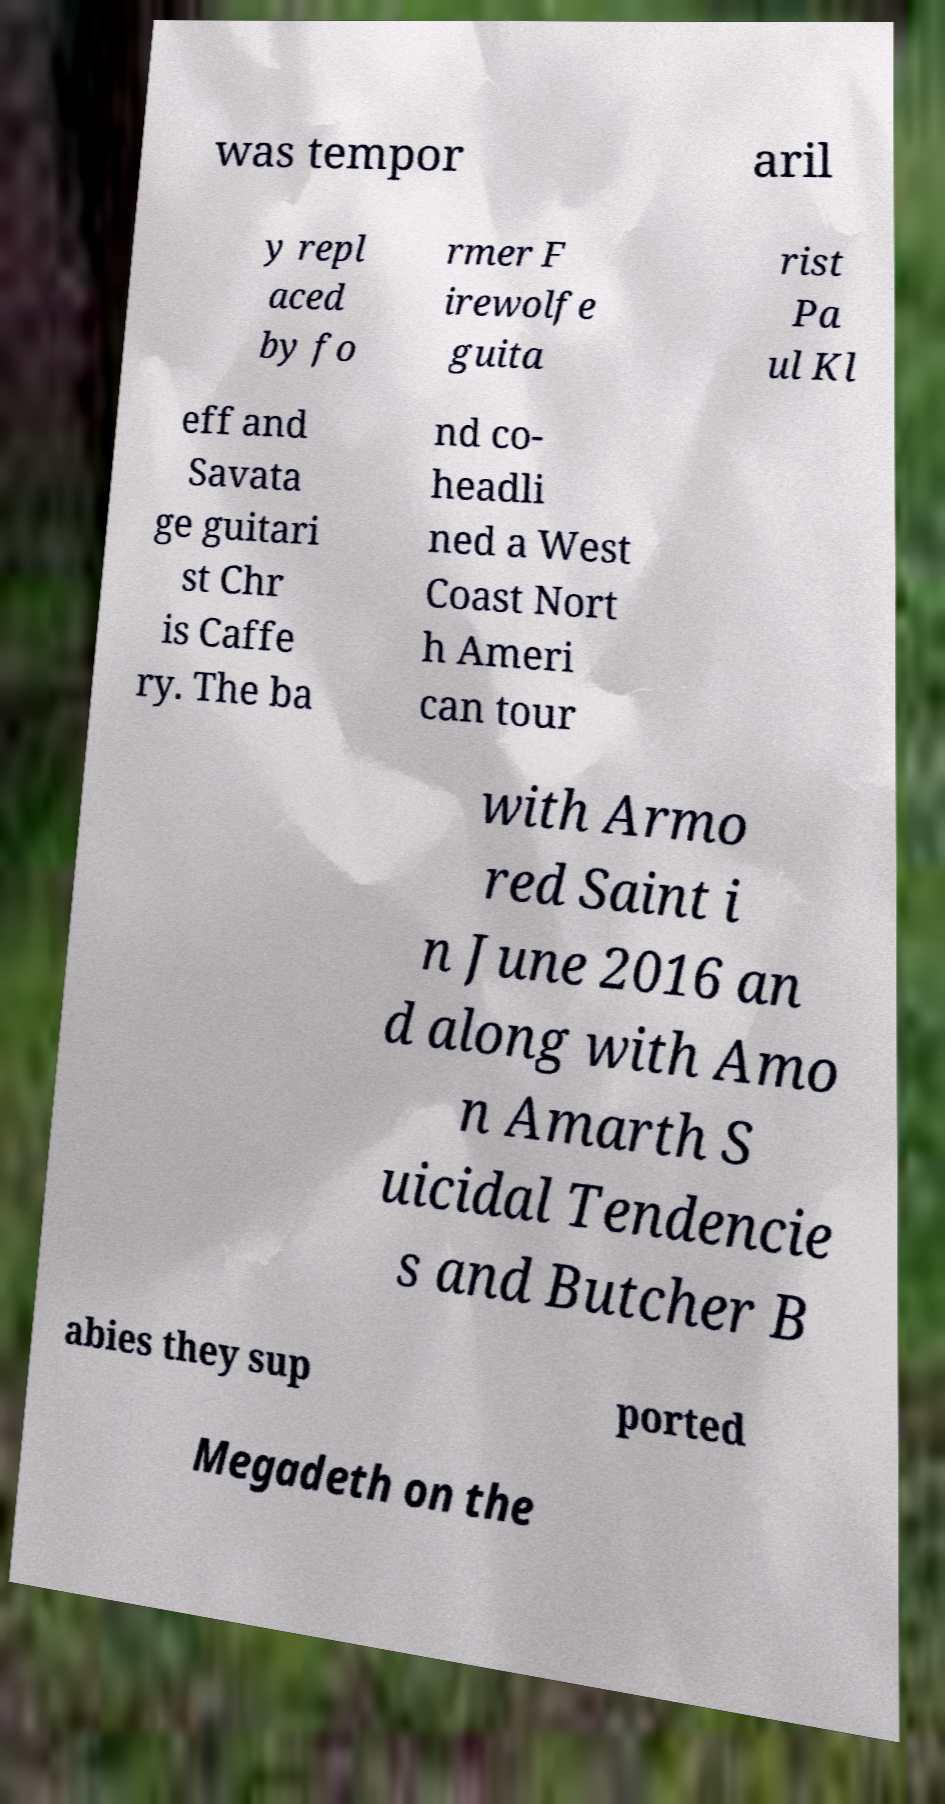I need the written content from this picture converted into text. Can you do that? was tempor aril y repl aced by fo rmer F irewolfe guita rist Pa ul Kl eff and Savata ge guitari st Chr is Caffe ry. The ba nd co- headli ned a West Coast Nort h Ameri can tour with Armo red Saint i n June 2016 an d along with Amo n Amarth S uicidal Tendencie s and Butcher B abies they sup ported Megadeth on the 